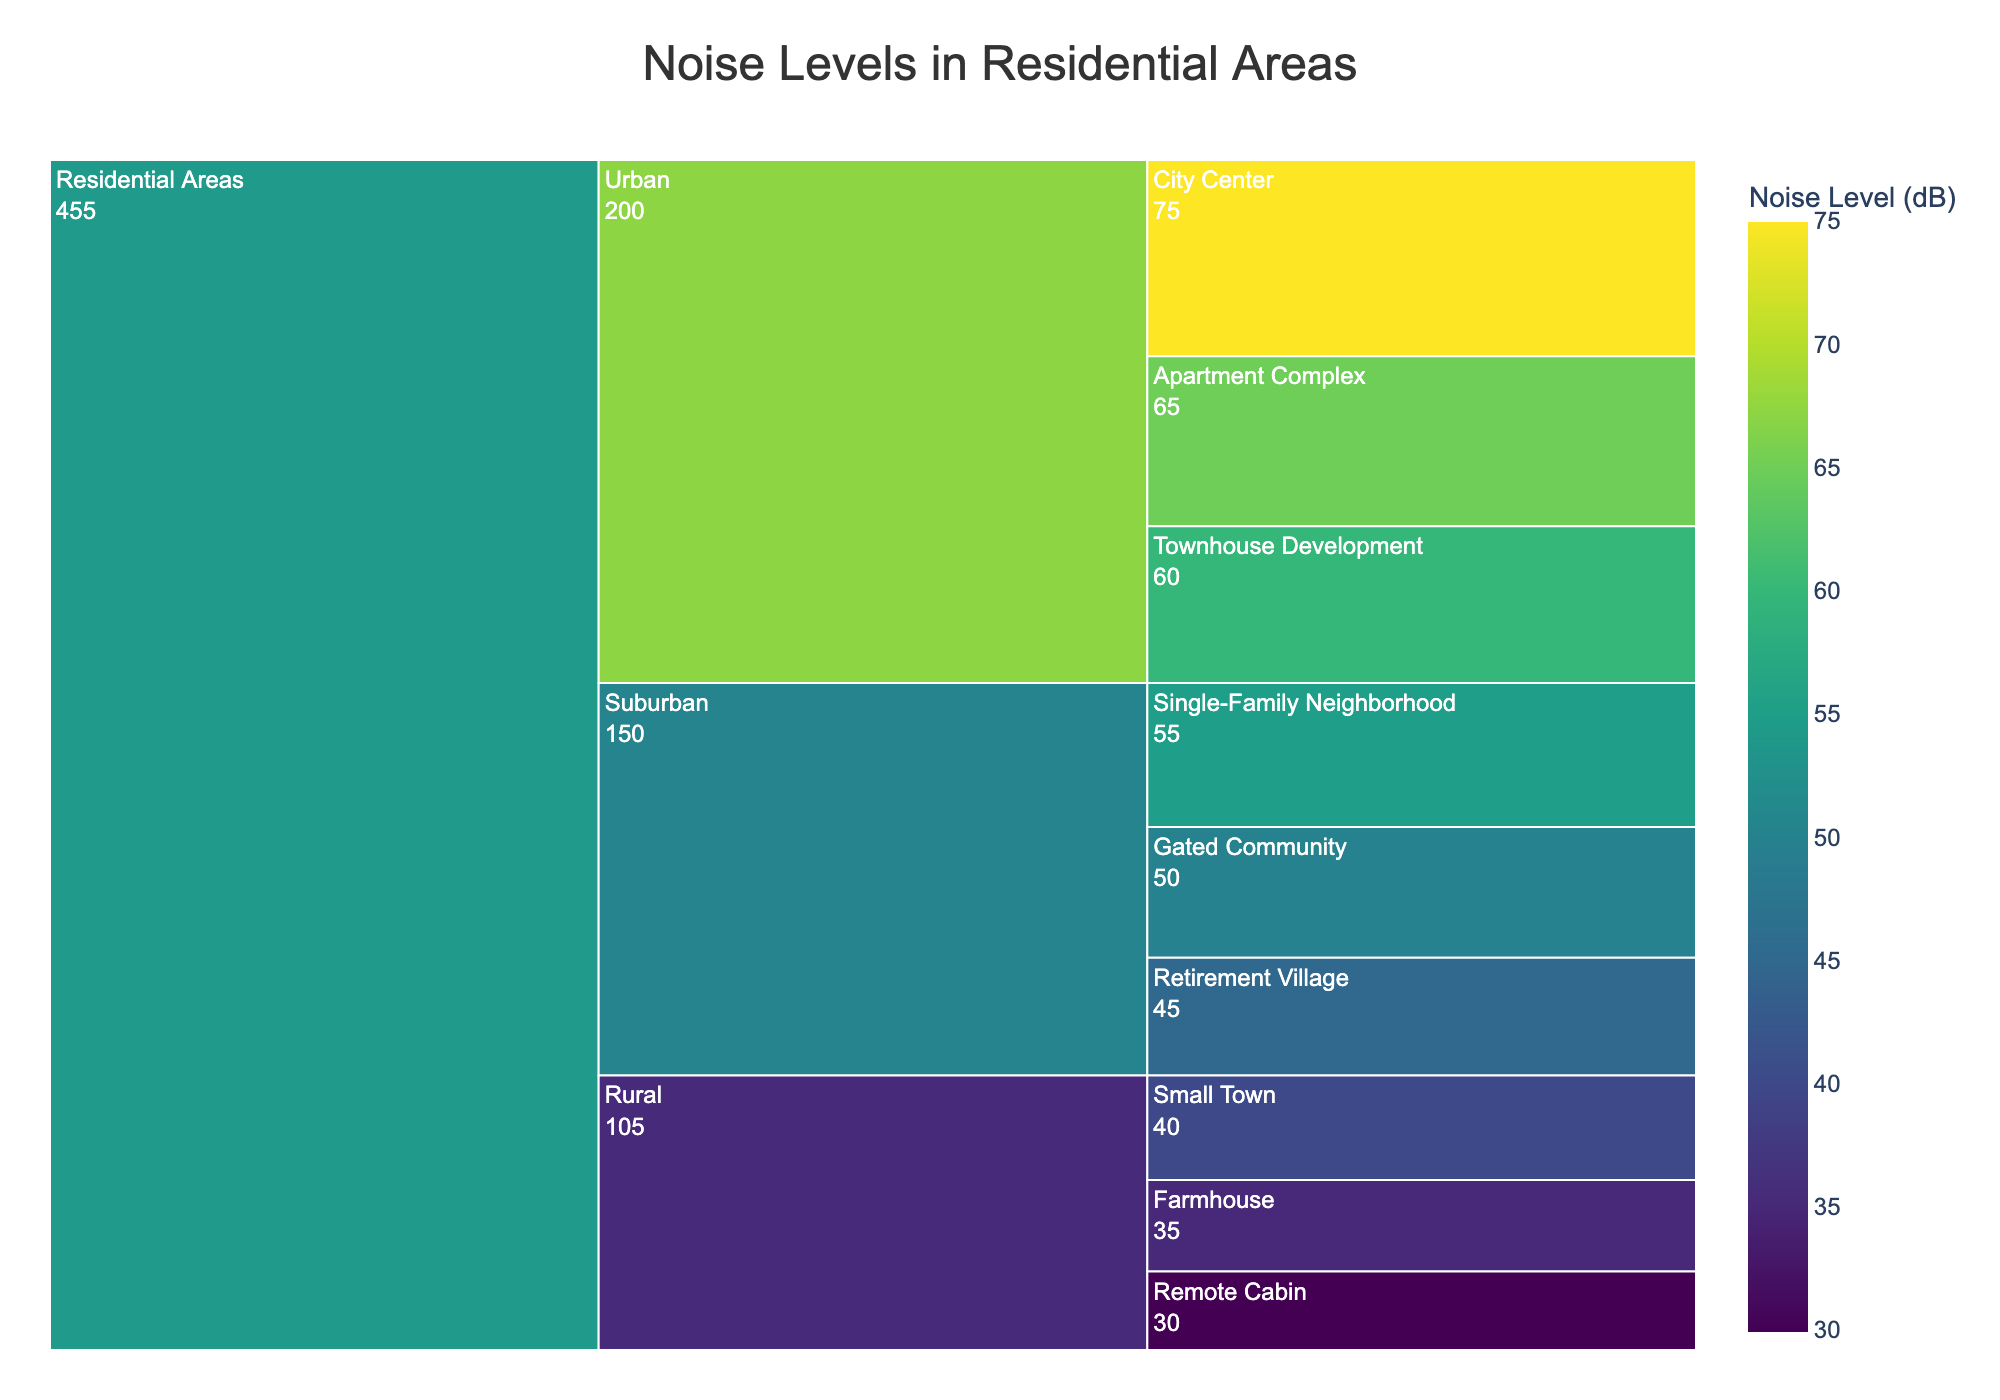What is the title of the figure? The title is typically displayed at the top of the chart. In this case, it mentions the main subject of the plot as "Noise Levels in Residential Areas".
Answer: Noise Levels in Residential Areas How are the residential areas categorized in the chart? By looking at the levels of hierarchy in the chart, we can see that residential areas are divided into three main categories: Urban, Suburban, and Rural.
Answer: Urban, Suburban, Rural Which subcategory in the Urban category has the highest noise level? We can observe each subcategory under the "Urban" category and compare their noise levels. The "City Center" has the highest noise level within Urban.
Answer: City Center What is the noise level in a Retirement Village? Locate the "Retirement Village" subcategory under the "Suburban" category and check its noise level, which is displayed on the chart.
Answer: 45 dB Which location has the lowest noise level in the Rural category? By comparing the noise levels of the subcategories within the "Rural" category, "Remote Cabin" has the lowest noise level.
Answer: Remote Cabin What's the difference in noise level between a City Center and a Remote Cabin? Subtract the noise level of "Remote Cabin" (30 dB) from the noise level of "City Center" (75 dB). The difference is 75 - 30.
Answer: 45 dB Which category has the overall lowest noise levels? By comparing the noise levels across the three main categories, we see that the "Rural" category has overall lower noise levels compared to Urban and Suburban.
Answer: Rural Which has a higher noise level: an Apartment Complex in Urban or a Single-Family Neighborhood in Suburban? Compare the noise levels of "Apartment Complex" (65 dB) and "Single-Family Neighborhood" (55 dB). The Apartment Complex has a higher level.
Answer: Apartment Complex What is the average noise level of the subcategories within the Suburban category? Add the noise levels of the Suburban subcategories (55 + 50 + 45) and divide by the number of subcategories (3). This results in (55 + 50 + 45) / 3 = 150 / 3.
Answer: 50 dB 